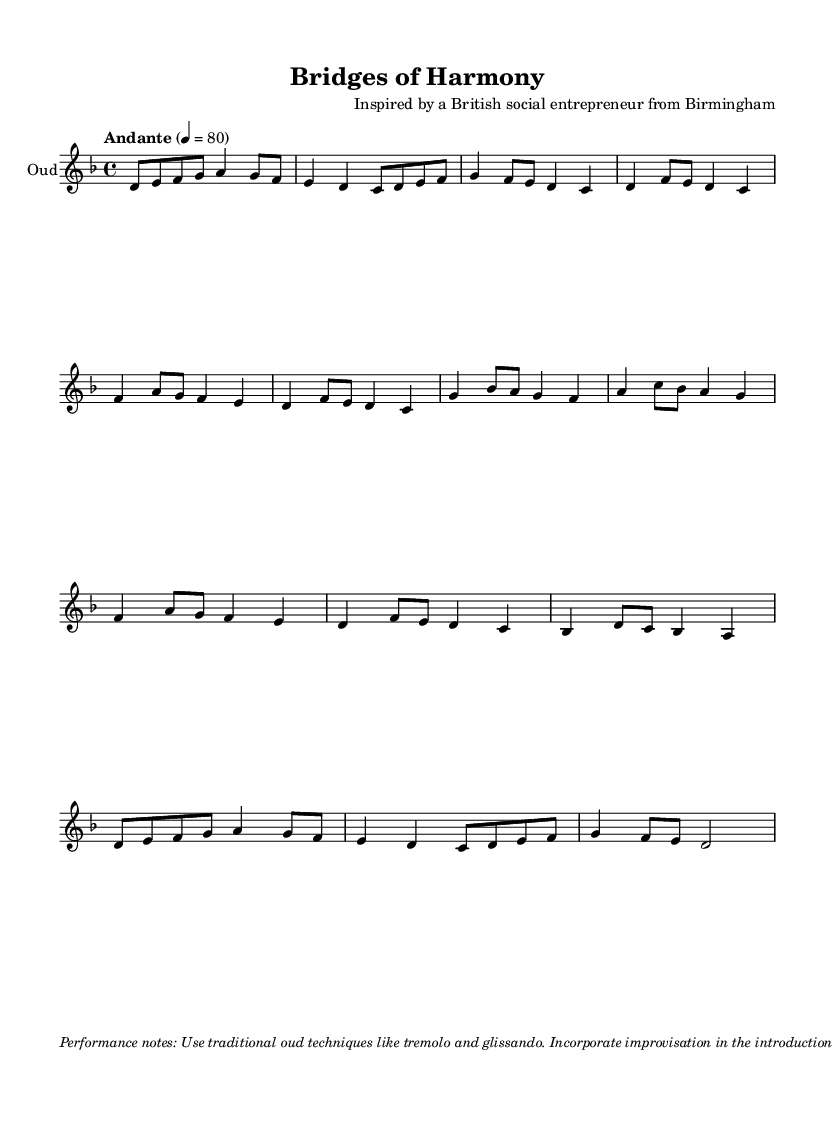What is the time signature of this music? The time signature is indicated at the beginning of the score as 4/4, which means there are four beats in each measure, and a quarter note receives one beat.
Answer: 4/4 What is the key signature of this music? The key signature is shown at the beginning of the score, which has one flat. This indicates it is in D minor, as D minor has one flat (B flat).
Answer: D minor What is the tempo of this composition? The tempo is marked as "Andante" with a metronome marking of 80 beats per minute. This indicates a moderately slow pace for the music.
Answer: Andante 80 What traditional oud techniques are suggested in the performance notes? The performance notes recommend using techniques like tremolo and glissando, which are common in oud playing to add expression and embellishment.
Answer: Tremolo and glissando How many sections are there in the composition? The score includes an introduction, Section A, Section B (partial), and a coda, indicating there are four main parts to the composition.
Answer: Four Which aspect reflects cross-cultural collaboration in this piece? The emphasis on incorporating improvisation and the connection between Eastern and Western musical elements showcases collaborative aspects between different musical traditions.
Answer: Improvisation and connection What role do microtonal inflections play in this piece? The performance notes highlight the importance of microtonal inflections, which are characteristic of Middle Eastern music and enhance the expressiveness of the oud.
Answer: Expressiveness 